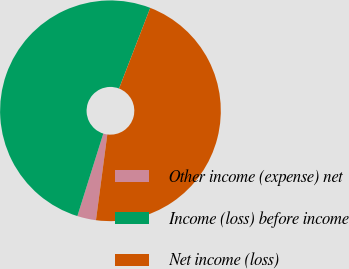<chart> <loc_0><loc_0><loc_500><loc_500><pie_chart><fcel>Other income (expense) net<fcel>Income (loss) before income<fcel>Net income (loss)<nl><fcel>2.75%<fcel>51.03%<fcel>46.22%<nl></chart> 